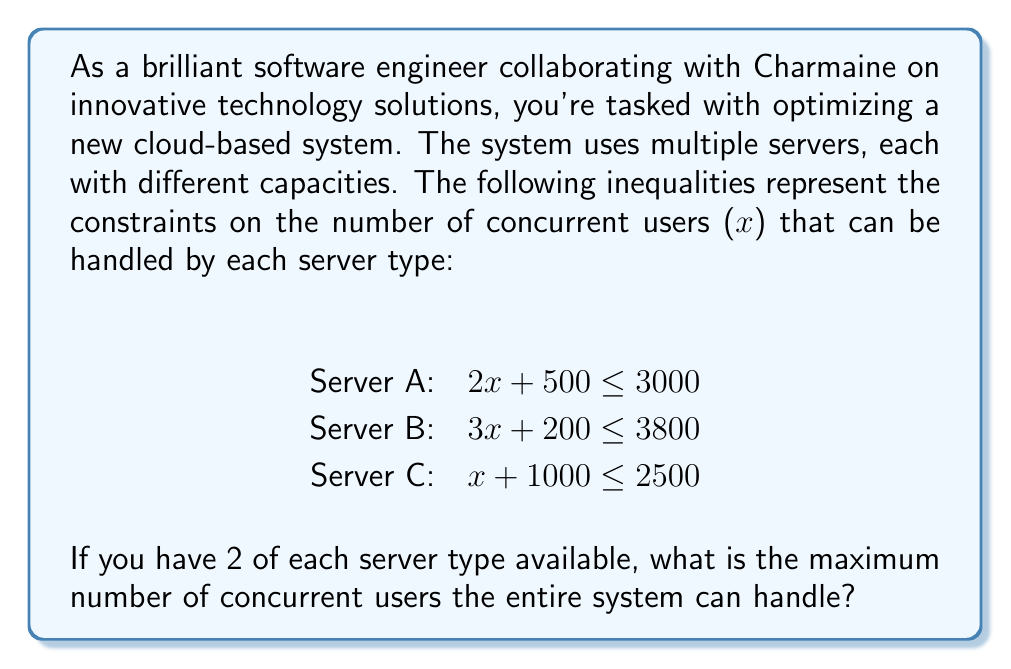Help me with this question. To solve this problem, we need to follow these steps:

1. Solve each inequality to find the maximum number of users for each server type:

   Server A: $2x + 500 \leq 3000$
             $2x \leq 2500$
             $x \leq 1250$

   Server B: $3x + 200 \leq 3800$
             $3x \leq 3600$
             $x \leq 1200$

   Server C: $x + 1000 \leq 2500$
             $x \leq 1500$

2. The maximum number of users for each server type:
   Server A: 1250 users
   Server B: 1200 users
   Server C: 1500 users

3. Since we have 2 of each server type, we multiply each result by 2:
   Server A: $2 \times 1250 = 2500$ users
   Server B: $2 \times 1200 = 2400$ users
   Server C: $2 \times 1500 = 3000$ users

4. The total maximum number of concurrent users is the sum of all servers:
   $2500 + 2400 + 3000 = 7900$ users

Therefore, the entire system can handle a maximum of 7900 concurrent users.
Answer: The maximum number of concurrent users the entire system can handle is 7900. 